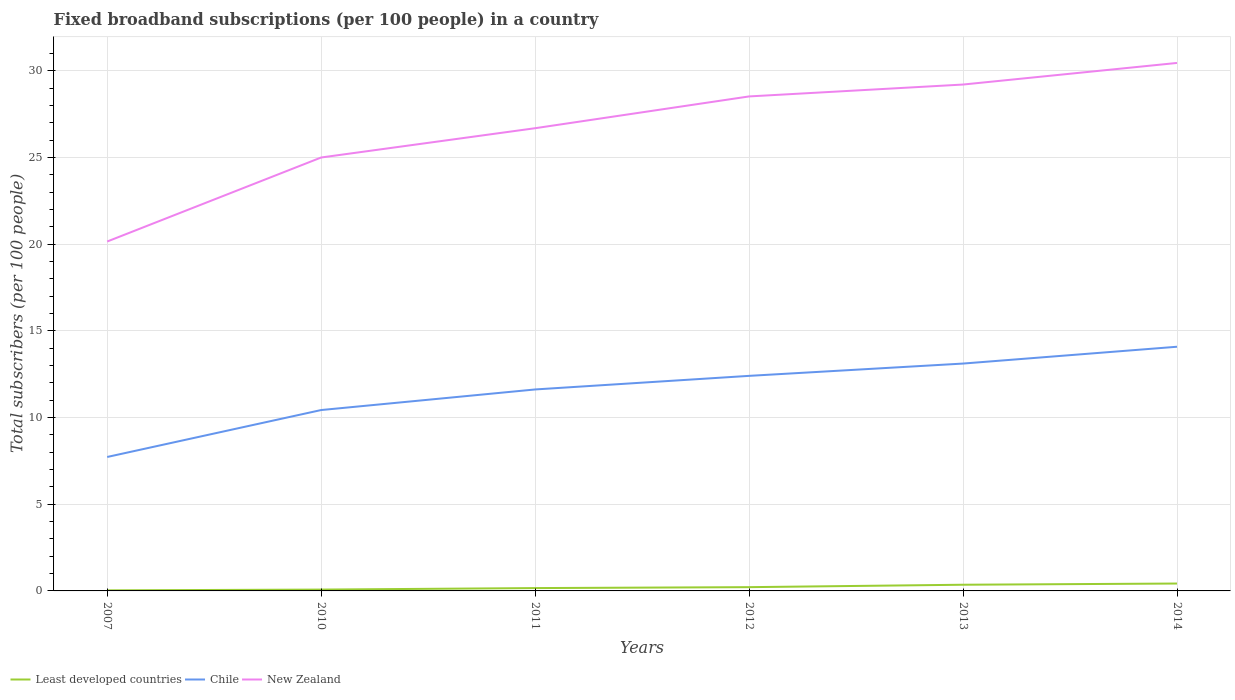Across all years, what is the maximum number of broadband subscriptions in Least developed countries?
Your answer should be very brief. 0.03. What is the total number of broadband subscriptions in Chile in the graph?
Your answer should be very brief. -6.36. What is the difference between the highest and the second highest number of broadband subscriptions in Least developed countries?
Keep it short and to the point. 0.39. Is the number of broadband subscriptions in New Zealand strictly greater than the number of broadband subscriptions in Chile over the years?
Make the answer very short. No. How many lines are there?
Provide a succinct answer. 3. How many years are there in the graph?
Ensure brevity in your answer.  6. Are the values on the major ticks of Y-axis written in scientific E-notation?
Your answer should be compact. No. Does the graph contain any zero values?
Provide a short and direct response. No. Where does the legend appear in the graph?
Offer a very short reply. Bottom left. What is the title of the graph?
Your response must be concise. Fixed broadband subscriptions (per 100 people) in a country. Does "Eritrea" appear as one of the legend labels in the graph?
Ensure brevity in your answer.  No. What is the label or title of the X-axis?
Your response must be concise. Years. What is the label or title of the Y-axis?
Offer a terse response. Total subscribers (per 100 people). What is the Total subscribers (per 100 people) in Least developed countries in 2007?
Give a very brief answer. 0.03. What is the Total subscribers (per 100 people) in Chile in 2007?
Make the answer very short. 7.73. What is the Total subscribers (per 100 people) in New Zealand in 2007?
Offer a very short reply. 20.15. What is the Total subscribers (per 100 people) in Least developed countries in 2010?
Make the answer very short. 0.08. What is the Total subscribers (per 100 people) in Chile in 2010?
Offer a very short reply. 10.43. What is the Total subscribers (per 100 people) in New Zealand in 2010?
Your answer should be compact. 25. What is the Total subscribers (per 100 people) in Least developed countries in 2011?
Ensure brevity in your answer.  0.16. What is the Total subscribers (per 100 people) of Chile in 2011?
Provide a succinct answer. 11.62. What is the Total subscribers (per 100 people) in New Zealand in 2011?
Keep it short and to the point. 26.69. What is the Total subscribers (per 100 people) in Least developed countries in 2012?
Offer a terse response. 0.22. What is the Total subscribers (per 100 people) in Chile in 2012?
Your answer should be very brief. 12.4. What is the Total subscribers (per 100 people) in New Zealand in 2012?
Your response must be concise. 28.52. What is the Total subscribers (per 100 people) in Least developed countries in 2013?
Provide a short and direct response. 0.36. What is the Total subscribers (per 100 people) in Chile in 2013?
Give a very brief answer. 13.11. What is the Total subscribers (per 100 people) of New Zealand in 2013?
Your response must be concise. 29.21. What is the Total subscribers (per 100 people) of Least developed countries in 2014?
Ensure brevity in your answer.  0.43. What is the Total subscribers (per 100 people) of Chile in 2014?
Your response must be concise. 14.08. What is the Total subscribers (per 100 people) of New Zealand in 2014?
Your response must be concise. 30.45. Across all years, what is the maximum Total subscribers (per 100 people) of Least developed countries?
Provide a succinct answer. 0.43. Across all years, what is the maximum Total subscribers (per 100 people) of Chile?
Offer a terse response. 14.08. Across all years, what is the maximum Total subscribers (per 100 people) in New Zealand?
Provide a succinct answer. 30.45. Across all years, what is the minimum Total subscribers (per 100 people) of Least developed countries?
Your response must be concise. 0.03. Across all years, what is the minimum Total subscribers (per 100 people) in Chile?
Your answer should be very brief. 7.73. Across all years, what is the minimum Total subscribers (per 100 people) of New Zealand?
Provide a short and direct response. 20.15. What is the total Total subscribers (per 100 people) of Least developed countries in the graph?
Your answer should be compact. 1.27. What is the total Total subscribers (per 100 people) in Chile in the graph?
Keep it short and to the point. 69.38. What is the total Total subscribers (per 100 people) in New Zealand in the graph?
Offer a very short reply. 160.02. What is the difference between the Total subscribers (per 100 people) of Least developed countries in 2007 and that in 2010?
Your response must be concise. -0.04. What is the difference between the Total subscribers (per 100 people) in Chile in 2007 and that in 2010?
Ensure brevity in your answer.  -2.71. What is the difference between the Total subscribers (per 100 people) of New Zealand in 2007 and that in 2010?
Ensure brevity in your answer.  -4.85. What is the difference between the Total subscribers (per 100 people) in Least developed countries in 2007 and that in 2011?
Keep it short and to the point. -0.13. What is the difference between the Total subscribers (per 100 people) of Chile in 2007 and that in 2011?
Your response must be concise. -3.89. What is the difference between the Total subscribers (per 100 people) in New Zealand in 2007 and that in 2011?
Your response must be concise. -6.54. What is the difference between the Total subscribers (per 100 people) of Least developed countries in 2007 and that in 2012?
Offer a very short reply. -0.18. What is the difference between the Total subscribers (per 100 people) of Chile in 2007 and that in 2012?
Make the answer very short. -4.68. What is the difference between the Total subscribers (per 100 people) of New Zealand in 2007 and that in 2012?
Give a very brief answer. -8.37. What is the difference between the Total subscribers (per 100 people) of Least developed countries in 2007 and that in 2013?
Provide a short and direct response. -0.32. What is the difference between the Total subscribers (per 100 people) in Chile in 2007 and that in 2013?
Provide a succinct answer. -5.39. What is the difference between the Total subscribers (per 100 people) in New Zealand in 2007 and that in 2013?
Give a very brief answer. -9.05. What is the difference between the Total subscribers (per 100 people) of Least developed countries in 2007 and that in 2014?
Keep it short and to the point. -0.39. What is the difference between the Total subscribers (per 100 people) in Chile in 2007 and that in 2014?
Provide a short and direct response. -6.36. What is the difference between the Total subscribers (per 100 people) in New Zealand in 2007 and that in 2014?
Make the answer very short. -10.3. What is the difference between the Total subscribers (per 100 people) in Least developed countries in 2010 and that in 2011?
Keep it short and to the point. -0.09. What is the difference between the Total subscribers (per 100 people) of Chile in 2010 and that in 2011?
Ensure brevity in your answer.  -1.19. What is the difference between the Total subscribers (per 100 people) in New Zealand in 2010 and that in 2011?
Offer a terse response. -1.69. What is the difference between the Total subscribers (per 100 people) in Least developed countries in 2010 and that in 2012?
Your response must be concise. -0.14. What is the difference between the Total subscribers (per 100 people) in Chile in 2010 and that in 2012?
Keep it short and to the point. -1.97. What is the difference between the Total subscribers (per 100 people) of New Zealand in 2010 and that in 2012?
Offer a very short reply. -3.52. What is the difference between the Total subscribers (per 100 people) of Least developed countries in 2010 and that in 2013?
Ensure brevity in your answer.  -0.28. What is the difference between the Total subscribers (per 100 people) of Chile in 2010 and that in 2013?
Your answer should be very brief. -2.68. What is the difference between the Total subscribers (per 100 people) in New Zealand in 2010 and that in 2013?
Your answer should be very brief. -4.21. What is the difference between the Total subscribers (per 100 people) of Least developed countries in 2010 and that in 2014?
Provide a short and direct response. -0.35. What is the difference between the Total subscribers (per 100 people) in Chile in 2010 and that in 2014?
Give a very brief answer. -3.65. What is the difference between the Total subscribers (per 100 people) in New Zealand in 2010 and that in 2014?
Provide a short and direct response. -5.45. What is the difference between the Total subscribers (per 100 people) in Least developed countries in 2011 and that in 2012?
Give a very brief answer. -0.05. What is the difference between the Total subscribers (per 100 people) in Chile in 2011 and that in 2012?
Make the answer very short. -0.78. What is the difference between the Total subscribers (per 100 people) of New Zealand in 2011 and that in 2012?
Give a very brief answer. -1.83. What is the difference between the Total subscribers (per 100 people) in Least developed countries in 2011 and that in 2013?
Your answer should be compact. -0.19. What is the difference between the Total subscribers (per 100 people) of Chile in 2011 and that in 2013?
Your answer should be compact. -1.49. What is the difference between the Total subscribers (per 100 people) in New Zealand in 2011 and that in 2013?
Make the answer very short. -2.52. What is the difference between the Total subscribers (per 100 people) of Least developed countries in 2011 and that in 2014?
Make the answer very short. -0.26. What is the difference between the Total subscribers (per 100 people) in Chile in 2011 and that in 2014?
Ensure brevity in your answer.  -2.46. What is the difference between the Total subscribers (per 100 people) in New Zealand in 2011 and that in 2014?
Your answer should be compact. -3.76. What is the difference between the Total subscribers (per 100 people) of Least developed countries in 2012 and that in 2013?
Give a very brief answer. -0.14. What is the difference between the Total subscribers (per 100 people) in Chile in 2012 and that in 2013?
Offer a very short reply. -0.71. What is the difference between the Total subscribers (per 100 people) of New Zealand in 2012 and that in 2013?
Make the answer very short. -0.69. What is the difference between the Total subscribers (per 100 people) in Least developed countries in 2012 and that in 2014?
Give a very brief answer. -0.21. What is the difference between the Total subscribers (per 100 people) of Chile in 2012 and that in 2014?
Keep it short and to the point. -1.68. What is the difference between the Total subscribers (per 100 people) of New Zealand in 2012 and that in 2014?
Give a very brief answer. -1.93. What is the difference between the Total subscribers (per 100 people) in Least developed countries in 2013 and that in 2014?
Ensure brevity in your answer.  -0.07. What is the difference between the Total subscribers (per 100 people) of Chile in 2013 and that in 2014?
Your answer should be very brief. -0.97. What is the difference between the Total subscribers (per 100 people) of New Zealand in 2013 and that in 2014?
Provide a short and direct response. -1.25. What is the difference between the Total subscribers (per 100 people) in Least developed countries in 2007 and the Total subscribers (per 100 people) in Chile in 2010?
Ensure brevity in your answer.  -10.4. What is the difference between the Total subscribers (per 100 people) in Least developed countries in 2007 and the Total subscribers (per 100 people) in New Zealand in 2010?
Your answer should be very brief. -24.97. What is the difference between the Total subscribers (per 100 people) in Chile in 2007 and the Total subscribers (per 100 people) in New Zealand in 2010?
Your answer should be very brief. -17.27. What is the difference between the Total subscribers (per 100 people) of Least developed countries in 2007 and the Total subscribers (per 100 people) of Chile in 2011?
Give a very brief answer. -11.59. What is the difference between the Total subscribers (per 100 people) of Least developed countries in 2007 and the Total subscribers (per 100 people) of New Zealand in 2011?
Offer a terse response. -26.66. What is the difference between the Total subscribers (per 100 people) of Chile in 2007 and the Total subscribers (per 100 people) of New Zealand in 2011?
Provide a succinct answer. -18.96. What is the difference between the Total subscribers (per 100 people) of Least developed countries in 2007 and the Total subscribers (per 100 people) of Chile in 2012?
Give a very brief answer. -12.37. What is the difference between the Total subscribers (per 100 people) in Least developed countries in 2007 and the Total subscribers (per 100 people) in New Zealand in 2012?
Your answer should be very brief. -28.49. What is the difference between the Total subscribers (per 100 people) in Chile in 2007 and the Total subscribers (per 100 people) in New Zealand in 2012?
Make the answer very short. -20.8. What is the difference between the Total subscribers (per 100 people) of Least developed countries in 2007 and the Total subscribers (per 100 people) of Chile in 2013?
Keep it short and to the point. -13.08. What is the difference between the Total subscribers (per 100 people) of Least developed countries in 2007 and the Total subscribers (per 100 people) of New Zealand in 2013?
Offer a terse response. -29.17. What is the difference between the Total subscribers (per 100 people) of Chile in 2007 and the Total subscribers (per 100 people) of New Zealand in 2013?
Give a very brief answer. -21.48. What is the difference between the Total subscribers (per 100 people) of Least developed countries in 2007 and the Total subscribers (per 100 people) of Chile in 2014?
Provide a succinct answer. -14.05. What is the difference between the Total subscribers (per 100 people) of Least developed countries in 2007 and the Total subscribers (per 100 people) of New Zealand in 2014?
Keep it short and to the point. -30.42. What is the difference between the Total subscribers (per 100 people) in Chile in 2007 and the Total subscribers (per 100 people) in New Zealand in 2014?
Provide a short and direct response. -22.73. What is the difference between the Total subscribers (per 100 people) in Least developed countries in 2010 and the Total subscribers (per 100 people) in Chile in 2011?
Keep it short and to the point. -11.54. What is the difference between the Total subscribers (per 100 people) of Least developed countries in 2010 and the Total subscribers (per 100 people) of New Zealand in 2011?
Provide a short and direct response. -26.61. What is the difference between the Total subscribers (per 100 people) in Chile in 2010 and the Total subscribers (per 100 people) in New Zealand in 2011?
Your answer should be compact. -16.26. What is the difference between the Total subscribers (per 100 people) in Least developed countries in 2010 and the Total subscribers (per 100 people) in Chile in 2012?
Your answer should be very brief. -12.33. What is the difference between the Total subscribers (per 100 people) in Least developed countries in 2010 and the Total subscribers (per 100 people) in New Zealand in 2012?
Provide a succinct answer. -28.44. What is the difference between the Total subscribers (per 100 people) in Chile in 2010 and the Total subscribers (per 100 people) in New Zealand in 2012?
Your answer should be very brief. -18.09. What is the difference between the Total subscribers (per 100 people) in Least developed countries in 2010 and the Total subscribers (per 100 people) in Chile in 2013?
Provide a short and direct response. -13.04. What is the difference between the Total subscribers (per 100 people) of Least developed countries in 2010 and the Total subscribers (per 100 people) of New Zealand in 2013?
Offer a very short reply. -29.13. What is the difference between the Total subscribers (per 100 people) of Chile in 2010 and the Total subscribers (per 100 people) of New Zealand in 2013?
Provide a succinct answer. -18.77. What is the difference between the Total subscribers (per 100 people) in Least developed countries in 2010 and the Total subscribers (per 100 people) in Chile in 2014?
Your answer should be compact. -14.01. What is the difference between the Total subscribers (per 100 people) of Least developed countries in 2010 and the Total subscribers (per 100 people) of New Zealand in 2014?
Provide a short and direct response. -30.38. What is the difference between the Total subscribers (per 100 people) of Chile in 2010 and the Total subscribers (per 100 people) of New Zealand in 2014?
Keep it short and to the point. -20.02. What is the difference between the Total subscribers (per 100 people) in Least developed countries in 2011 and the Total subscribers (per 100 people) in Chile in 2012?
Your response must be concise. -12.24. What is the difference between the Total subscribers (per 100 people) in Least developed countries in 2011 and the Total subscribers (per 100 people) in New Zealand in 2012?
Keep it short and to the point. -28.36. What is the difference between the Total subscribers (per 100 people) in Chile in 2011 and the Total subscribers (per 100 people) in New Zealand in 2012?
Keep it short and to the point. -16.9. What is the difference between the Total subscribers (per 100 people) of Least developed countries in 2011 and the Total subscribers (per 100 people) of Chile in 2013?
Your answer should be very brief. -12.95. What is the difference between the Total subscribers (per 100 people) in Least developed countries in 2011 and the Total subscribers (per 100 people) in New Zealand in 2013?
Give a very brief answer. -29.04. What is the difference between the Total subscribers (per 100 people) of Chile in 2011 and the Total subscribers (per 100 people) of New Zealand in 2013?
Your answer should be compact. -17.59. What is the difference between the Total subscribers (per 100 people) of Least developed countries in 2011 and the Total subscribers (per 100 people) of Chile in 2014?
Ensure brevity in your answer.  -13.92. What is the difference between the Total subscribers (per 100 people) of Least developed countries in 2011 and the Total subscribers (per 100 people) of New Zealand in 2014?
Your response must be concise. -30.29. What is the difference between the Total subscribers (per 100 people) in Chile in 2011 and the Total subscribers (per 100 people) in New Zealand in 2014?
Your answer should be compact. -18.83. What is the difference between the Total subscribers (per 100 people) in Least developed countries in 2012 and the Total subscribers (per 100 people) in Chile in 2013?
Give a very brief answer. -12.9. What is the difference between the Total subscribers (per 100 people) of Least developed countries in 2012 and the Total subscribers (per 100 people) of New Zealand in 2013?
Offer a very short reply. -28.99. What is the difference between the Total subscribers (per 100 people) in Chile in 2012 and the Total subscribers (per 100 people) in New Zealand in 2013?
Offer a terse response. -16.8. What is the difference between the Total subscribers (per 100 people) of Least developed countries in 2012 and the Total subscribers (per 100 people) of Chile in 2014?
Provide a succinct answer. -13.87. What is the difference between the Total subscribers (per 100 people) of Least developed countries in 2012 and the Total subscribers (per 100 people) of New Zealand in 2014?
Ensure brevity in your answer.  -30.24. What is the difference between the Total subscribers (per 100 people) in Chile in 2012 and the Total subscribers (per 100 people) in New Zealand in 2014?
Ensure brevity in your answer.  -18.05. What is the difference between the Total subscribers (per 100 people) in Least developed countries in 2013 and the Total subscribers (per 100 people) in Chile in 2014?
Provide a short and direct response. -13.73. What is the difference between the Total subscribers (per 100 people) of Least developed countries in 2013 and the Total subscribers (per 100 people) of New Zealand in 2014?
Offer a terse response. -30.1. What is the difference between the Total subscribers (per 100 people) in Chile in 2013 and the Total subscribers (per 100 people) in New Zealand in 2014?
Ensure brevity in your answer.  -17.34. What is the average Total subscribers (per 100 people) in Least developed countries per year?
Your response must be concise. 0.21. What is the average Total subscribers (per 100 people) of Chile per year?
Offer a very short reply. 11.56. What is the average Total subscribers (per 100 people) of New Zealand per year?
Make the answer very short. 26.67. In the year 2007, what is the difference between the Total subscribers (per 100 people) of Least developed countries and Total subscribers (per 100 people) of Chile?
Keep it short and to the point. -7.69. In the year 2007, what is the difference between the Total subscribers (per 100 people) in Least developed countries and Total subscribers (per 100 people) in New Zealand?
Make the answer very short. -20.12. In the year 2007, what is the difference between the Total subscribers (per 100 people) of Chile and Total subscribers (per 100 people) of New Zealand?
Keep it short and to the point. -12.43. In the year 2010, what is the difference between the Total subscribers (per 100 people) in Least developed countries and Total subscribers (per 100 people) in Chile?
Provide a succinct answer. -10.36. In the year 2010, what is the difference between the Total subscribers (per 100 people) of Least developed countries and Total subscribers (per 100 people) of New Zealand?
Provide a short and direct response. -24.92. In the year 2010, what is the difference between the Total subscribers (per 100 people) in Chile and Total subscribers (per 100 people) in New Zealand?
Offer a terse response. -14.57. In the year 2011, what is the difference between the Total subscribers (per 100 people) of Least developed countries and Total subscribers (per 100 people) of Chile?
Offer a very short reply. -11.46. In the year 2011, what is the difference between the Total subscribers (per 100 people) in Least developed countries and Total subscribers (per 100 people) in New Zealand?
Your answer should be very brief. -26.52. In the year 2011, what is the difference between the Total subscribers (per 100 people) in Chile and Total subscribers (per 100 people) in New Zealand?
Ensure brevity in your answer.  -15.07. In the year 2012, what is the difference between the Total subscribers (per 100 people) in Least developed countries and Total subscribers (per 100 people) in Chile?
Offer a terse response. -12.19. In the year 2012, what is the difference between the Total subscribers (per 100 people) of Least developed countries and Total subscribers (per 100 people) of New Zealand?
Your answer should be compact. -28.3. In the year 2012, what is the difference between the Total subscribers (per 100 people) of Chile and Total subscribers (per 100 people) of New Zealand?
Provide a succinct answer. -16.12. In the year 2013, what is the difference between the Total subscribers (per 100 people) in Least developed countries and Total subscribers (per 100 people) in Chile?
Your answer should be compact. -12.76. In the year 2013, what is the difference between the Total subscribers (per 100 people) in Least developed countries and Total subscribers (per 100 people) in New Zealand?
Your answer should be very brief. -28.85. In the year 2013, what is the difference between the Total subscribers (per 100 people) of Chile and Total subscribers (per 100 people) of New Zealand?
Ensure brevity in your answer.  -16.09. In the year 2014, what is the difference between the Total subscribers (per 100 people) in Least developed countries and Total subscribers (per 100 people) in Chile?
Offer a very short reply. -13.66. In the year 2014, what is the difference between the Total subscribers (per 100 people) in Least developed countries and Total subscribers (per 100 people) in New Zealand?
Keep it short and to the point. -30.03. In the year 2014, what is the difference between the Total subscribers (per 100 people) of Chile and Total subscribers (per 100 people) of New Zealand?
Offer a terse response. -16.37. What is the ratio of the Total subscribers (per 100 people) of Least developed countries in 2007 to that in 2010?
Keep it short and to the point. 0.43. What is the ratio of the Total subscribers (per 100 people) in Chile in 2007 to that in 2010?
Your response must be concise. 0.74. What is the ratio of the Total subscribers (per 100 people) of New Zealand in 2007 to that in 2010?
Keep it short and to the point. 0.81. What is the ratio of the Total subscribers (per 100 people) of Least developed countries in 2007 to that in 2011?
Keep it short and to the point. 0.2. What is the ratio of the Total subscribers (per 100 people) in Chile in 2007 to that in 2011?
Offer a very short reply. 0.66. What is the ratio of the Total subscribers (per 100 people) of New Zealand in 2007 to that in 2011?
Make the answer very short. 0.76. What is the ratio of the Total subscribers (per 100 people) in Least developed countries in 2007 to that in 2012?
Your answer should be very brief. 0.15. What is the ratio of the Total subscribers (per 100 people) in Chile in 2007 to that in 2012?
Keep it short and to the point. 0.62. What is the ratio of the Total subscribers (per 100 people) of New Zealand in 2007 to that in 2012?
Your answer should be very brief. 0.71. What is the ratio of the Total subscribers (per 100 people) of Least developed countries in 2007 to that in 2013?
Give a very brief answer. 0.09. What is the ratio of the Total subscribers (per 100 people) of Chile in 2007 to that in 2013?
Give a very brief answer. 0.59. What is the ratio of the Total subscribers (per 100 people) of New Zealand in 2007 to that in 2013?
Your answer should be compact. 0.69. What is the ratio of the Total subscribers (per 100 people) of Least developed countries in 2007 to that in 2014?
Offer a very short reply. 0.08. What is the ratio of the Total subscribers (per 100 people) in Chile in 2007 to that in 2014?
Your response must be concise. 0.55. What is the ratio of the Total subscribers (per 100 people) of New Zealand in 2007 to that in 2014?
Give a very brief answer. 0.66. What is the ratio of the Total subscribers (per 100 people) in Least developed countries in 2010 to that in 2011?
Provide a short and direct response. 0.47. What is the ratio of the Total subscribers (per 100 people) in Chile in 2010 to that in 2011?
Ensure brevity in your answer.  0.9. What is the ratio of the Total subscribers (per 100 people) in New Zealand in 2010 to that in 2011?
Keep it short and to the point. 0.94. What is the ratio of the Total subscribers (per 100 people) of Least developed countries in 2010 to that in 2012?
Make the answer very short. 0.36. What is the ratio of the Total subscribers (per 100 people) of Chile in 2010 to that in 2012?
Your response must be concise. 0.84. What is the ratio of the Total subscribers (per 100 people) of New Zealand in 2010 to that in 2012?
Offer a terse response. 0.88. What is the ratio of the Total subscribers (per 100 people) of Least developed countries in 2010 to that in 2013?
Your response must be concise. 0.22. What is the ratio of the Total subscribers (per 100 people) in Chile in 2010 to that in 2013?
Make the answer very short. 0.8. What is the ratio of the Total subscribers (per 100 people) of New Zealand in 2010 to that in 2013?
Your answer should be very brief. 0.86. What is the ratio of the Total subscribers (per 100 people) in Least developed countries in 2010 to that in 2014?
Your answer should be very brief. 0.18. What is the ratio of the Total subscribers (per 100 people) of Chile in 2010 to that in 2014?
Make the answer very short. 0.74. What is the ratio of the Total subscribers (per 100 people) of New Zealand in 2010 to that in 2014?
Make the answer very short. 0.82. What is the ratio of the Total subscribers (per 100 people) of Least developed countries in 2011 to that in 2012?
Give a very brief answer. 0.76. What is the ratio of the Total subscribers (per 100 people) in Chile in 2011 to that in 2012?
Provide a short and direct response. 0.94. What is the ratio of the Total subscribers (per 100 people) of New Zealand in 2011 to that in 2012?
Your answer should be compact. 0.94. What is the ratio of the Total subscribers (per 100 people) in Least developed countries in 2011 to that in 2013?
Your answer should be very brief. 0.46. What is the ratio of the Total subscribers (per 100 people) in Chile in 2011 to that in 2013?
Keep it short and to the point. 0.89. What is the ratio of the Total subscribers (per 100 people) of New Zealand in 2011 to that in 2013?
Provide a succinct answer. 0.91. What is the ratio of the Total subscribers (per 100 people) in Least developed countries in 2011 to that in 2014?
Your response must be concise. 0.38. What is the ratio of the Total subscribers (per 100 people) of Chile in 2011 to that in 2014?
Provide a succinct answer. 0.83. What is the ratio of the Total subscribers (per 100 people) in New Zealand in 2011 to that in 2014?
Your answer should be compact. 0.88. What is the ratio of the Total subscribers (per 100 people) of Least developed countries in 2012 to that in 2013?
Offer a terse response. 0.61. What is the ratio of the Total subscribers (per 100 people) in Chile in 2012 to that in 2013?
Offer a terse response. 0.95. What is the ratio of the Total subscribers (per 100 people) of New Zealand in 2012 to that in 2013?
Keep it short and to the point. 0.98. What is the ratio of the Total subscribers (per 100 people) of Least developed countries in 2012 to that in 2014?
Your answer should be compact. 0.51. What is the ratio of the Total subscribers (per 100 people) of Chile in 2012 to that in 2014?
Give a very brief answer. 0.88. What is the ratio of the Total subscribers (per 100 people) in New Zealand in 2012 to that in 2014?
Your answer should be compact. 0.94. What is the ratio of the Total subscribers (per 100 people) of Least developed countries in 2013 to that in 2014?
Offer a terse response. 0.84. What is the ratio of the Total subscribers (per 100 people) of Chile in 2013 to that in 2014?
Offer a terse response. 0.93. What is the ratio of the Total subscribers (per 100 people) of New Zealand in 2013 to that in 2014?
Your answer should be compact. 0.96. What is the difference between the highest and the second highest Total subscribers (per 100 people) of Least developed countries?
Provide a succinct answer. 0.07. What is the difference between the highest and the second highest Total subscribers (per 100 people) of Chile?
Your answer should be very brief. 0.97. What is the difference between the highest and the second highest Total subscribers (per 100 people) in New Zealand?
Provide a succinct answer. 1.25. What is the difference between the highest and the lowest Total subscribers (per 100 people) of Least developed countries?
Give a very brief answer. 0.39. What is the difference between the highest and the lowest Total subscribers (per 100 people) of Chile?
Your answer should be compact. 6.36. What is the difference between the highest and the lowest Total subscribers (per 100 people) of New Zealand?
Give a very brief answer. 10.3. 